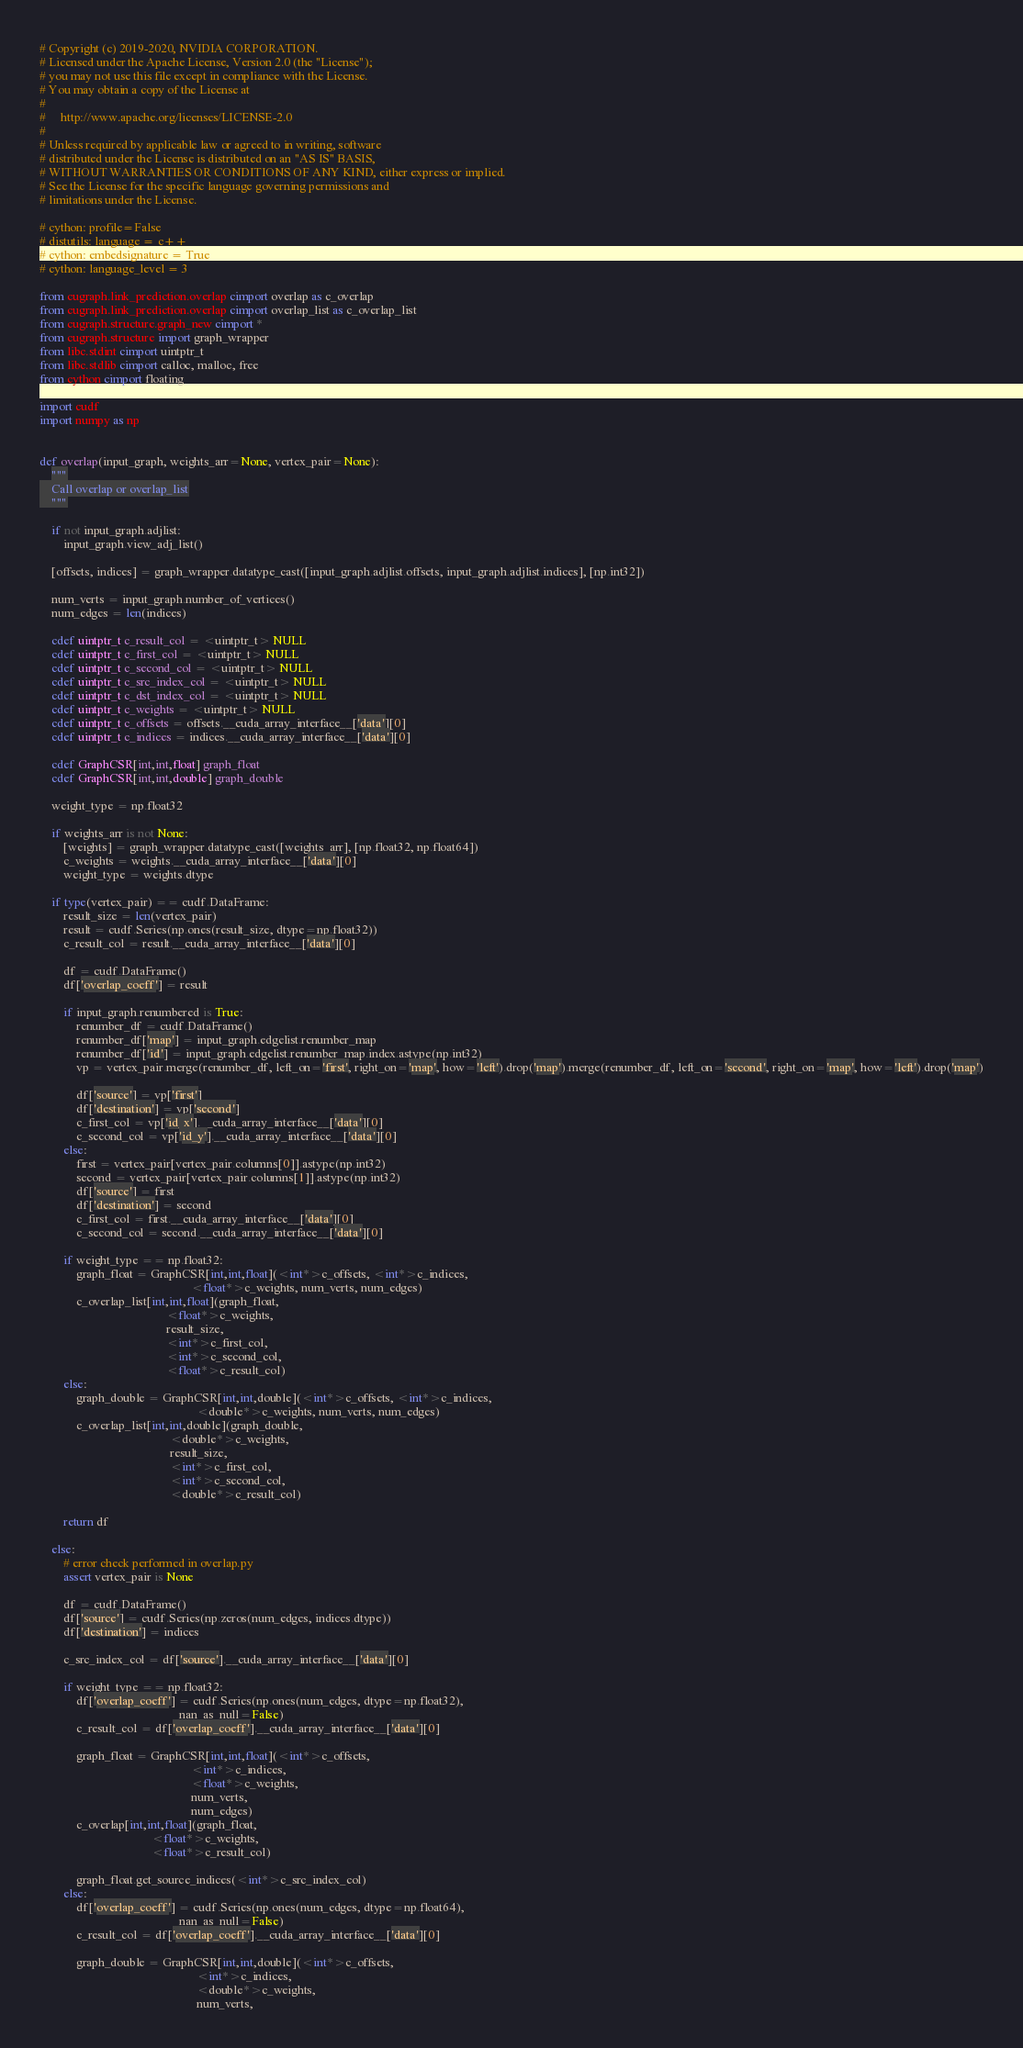<code> <loc_0><loc_0><loc_500><loc_500><_Cython_># Copyright (c) 2019-2020, NVIDIA CORPORATION.
# Licensed under the Apache License, Version 2.0 (the "License");
# you may not use this file except in compliance with the License.
# You may obtain a copy of the License at
#
#     http://www.apache.org/licenses/LICENSE-2.0
#
# Unless required by applicable law or agreed to in writing, software
# distributed under the License is distributed on an "AS IS" BASIS,
# WITHOUT WARRANTIES OR CONDITIONS OF ANY KIND, either express or implied.
# See the License for the specific language governing permissions and
# limitations under the License.

# cython: profile=False
# distutils: language = c++
# cython: embedsignature = True
# cython: language_level = 3

from cugraph.link_prediction.overlap cimport overlap as c_overlap
from cugraph.link_prediction.overlap cimport overlap_list as c_overlap_list
from cugraph.structure.graph_new cimport *
from cugraph.structure import graph_wrapper
from libc.stdint cimport uintptr_t
from libc.stdlib cimport calloc, malloc, free
from cython cimport floating

import cudf
import numpy as np


def overlap(input_graph, weights_arr=None, vertex_pair=None):
    """
    Call overlap or overlap_list
    """

    if not input_graph.adjlist:
        input_graph.view_adj_list()

    [offsets, indices] = graph_wrapper.datatype_cast([input_graph.adjlist.offsets, input_graph.adjlist.indices], [np.int32])

    num_verts = input_graph.number_of_vertices()
    num_edges = len(indices)

    cdef uintptr_t c_result_col = <uintptr_t> NULL
    cdef uintptr_t c_first_col = <uintptr_t> NULL
    cdef uintptr_t c_second_col = <uintptr_t> NULL
    cdef uintptr_t c_src_index_col = <uintptr_t> NULL
    cdef uintptr_t c_dst_index_col = <uintptr_t> NULL
    cdef uintptr_t c_weights = <uintptr_t> NULL
    cdef uintptr_t c_offsets = offsets.__cuda_array_interface__['data'][0]
    cdef uintptr_t c_indices = indices.__cuda_array_interface__['data'][0]

    cdef GraphCSR[int,int,float] graph_float
    cdef GraphCSR[int,int,double] graph_double

    weight_type = np.float32

    if weights_arr is not None:
        [weights] = graph_wrapper.datatype_cast([weights_arr], [np.float32, np.float64])
        c_weights = weights.__cuda_array_interface__['data'][0]
        weight_type = weights.dtype

    if type(vertex_pair) == cudf.DataFrame:
        result_size = len(vertex_pair)
        result = cudf.Series(np.ones(result_size, dtype=np.float32))
        c_result_col = result.__cuda_array_interface__['data'][0]

        df = cudf.DataFrame()
        df['overlap_coeff'] = result
        
        if input_graph.renumbered is True:
            renumber_df = cudf.DataFrame()
            renumber_df['map'] = input_graph.edgelist.renumber_map
            renumber_df['id'] = input_graph.edgelist.renumber_map.index.astype(np.int32)
            vp = vertex_pair.merge(renumber_df, left_on='first', right_on='map', how='left').drop('map').merge(renumber_df, left_on='second', right_on='map', how='left').drop('map')

            df['source'] = vp['first']
            df['destination'] = vp['second']
            c_first_col = vp['id_x'].__cuda_array_interface__['data'][0]
            c_second_col = vp['id_y'].__cuda_array_interface__['data'][0]
        else:
            first = vertex_pair[vertex_pair.columns[0]].astype(np.int32)
            second = vertex_pair[vertex_pair.columns[1]].astype(np.int32)
            df['source'] = first
            df['destination'] = second
            c_first_col = first.__cuda_array_interface__['data'][0]
            c_second_col = second.__cuda_array_interface__['data'][0]

        if weight_type == np.float32:
            graph_float = GraphCSR[int,int,float](<int*>c_offsets, <int*>c_indices,
                                                  <float*>c_weights, num_verts, num_edges)
            c_overlap_list[int,int,float](graph_float,
                                          <float*>c_weights,
                                          result_size,
                                          <int*>c_first_col,
                                          <int*>c_second_col,
                                          <float*>c_result_col)
        else:
            graph_double = GraphCSR[int,int,double](<int*>c_offsets, <int*>c_indices,
                                                    <double*>c_weights, num_verts, num_edges)
            c_overlap_list[int,int,double](graph_double,
                                           <double*>c_weights,
                                           result_size,
                                           <int*>c_first_col,
                                           <int*>c_second_col,
                                           <double*>c_result_col)
        
        return df

    else:
        # error check performed in overlap.py
        assert vertex_pair is None

        df = cudf.DataFrame()
        df['source'] = cudf.Series(np.zeros(num_edges, indices.dtype))
        df['destination'] = indices

        c_src_index_col = df['source'].__cuda_array_interface__['data'][0]

        if weight_type == np.float32:
            df['overlap_coeff'] = cudf.Series(np.ones(num_edges, dtype=np.float32),
                                              nan_as_null=False)
            c_result_col = df['overlap_coeff'].__cuda_array_interface__['data'][0]

            graph_float = GraphCSR[int,int,float](<int*>c_offsets,
                                                  <int*>c_indices,
                                                  <float*>c_weights,
                                                  num_verts,
                                                  num_edges)
            c_overlap[int,int,float](graph_float,
                                     <float*>c_weights,
                                     <float*>c_result_col)

            graph_float.get_source_indices(<int*>c_src_index_col)
        else:
            df['overlap_coeff'] = cudf.Series(np.ones(num_edges, dtype=np.float64),
                                              nan_as_null=False)
            c_result_col = df['overlap_coeff'].__cuda_array_interface__['data'][0]

            graph_double = GraphCSR[int,int,double](<int*>c_offsets,
                                                    <int*>c_indices,
                                                    <double*>c_weights,
                                                    num_verts,</code> 